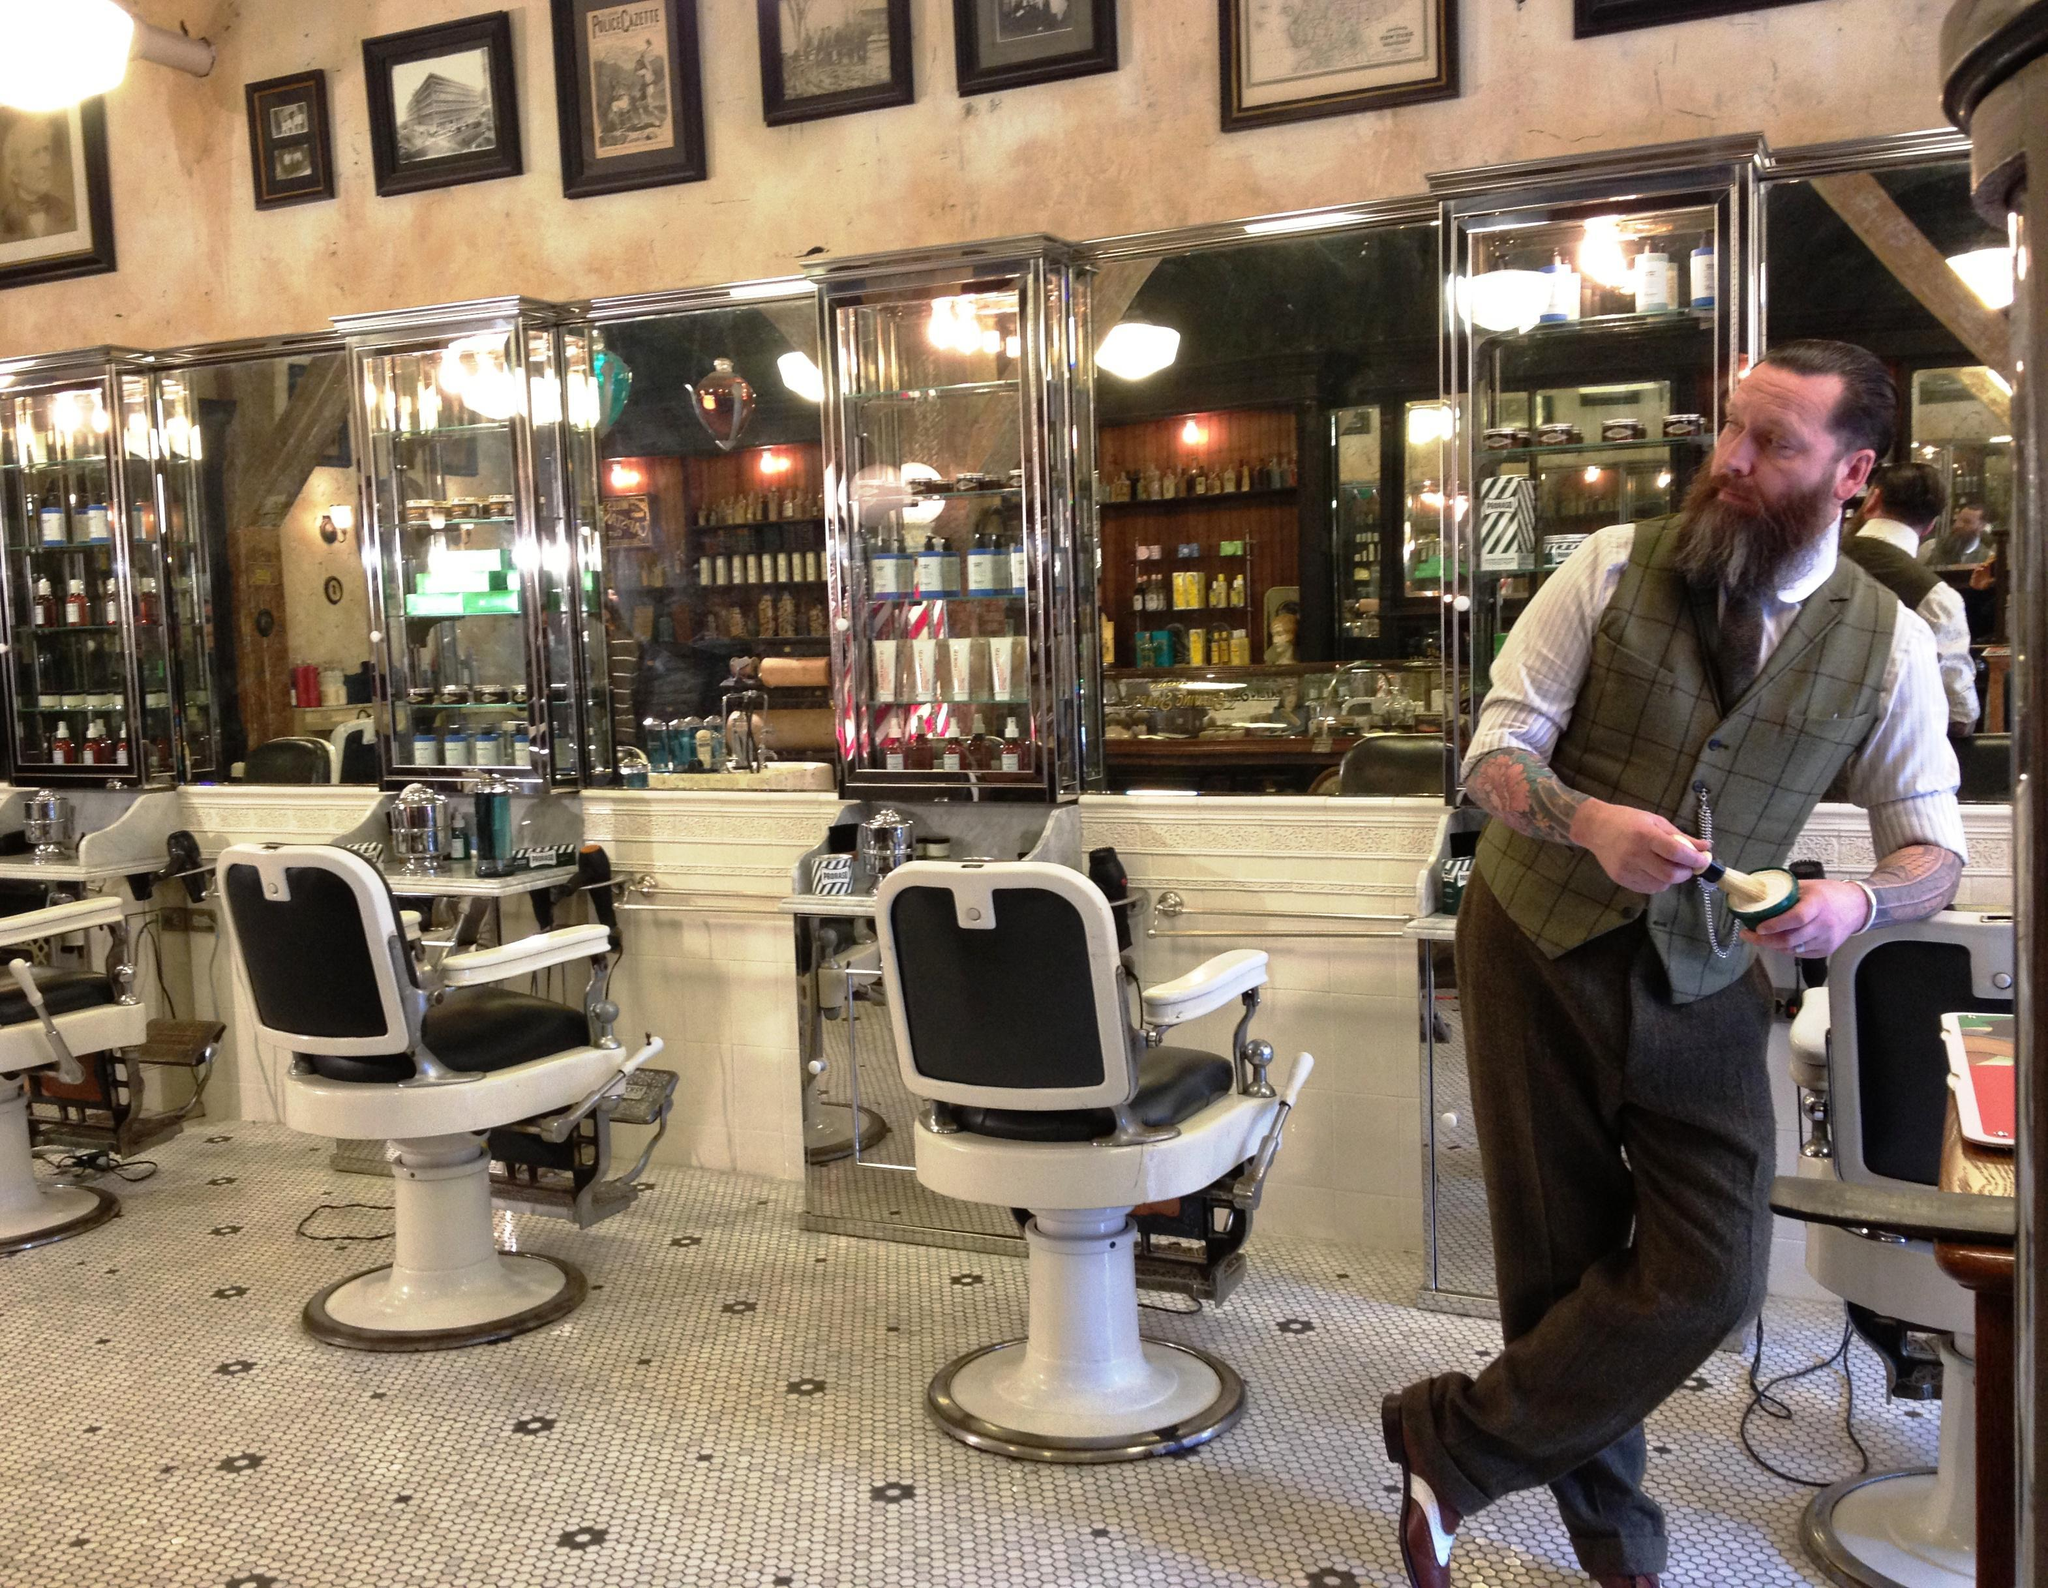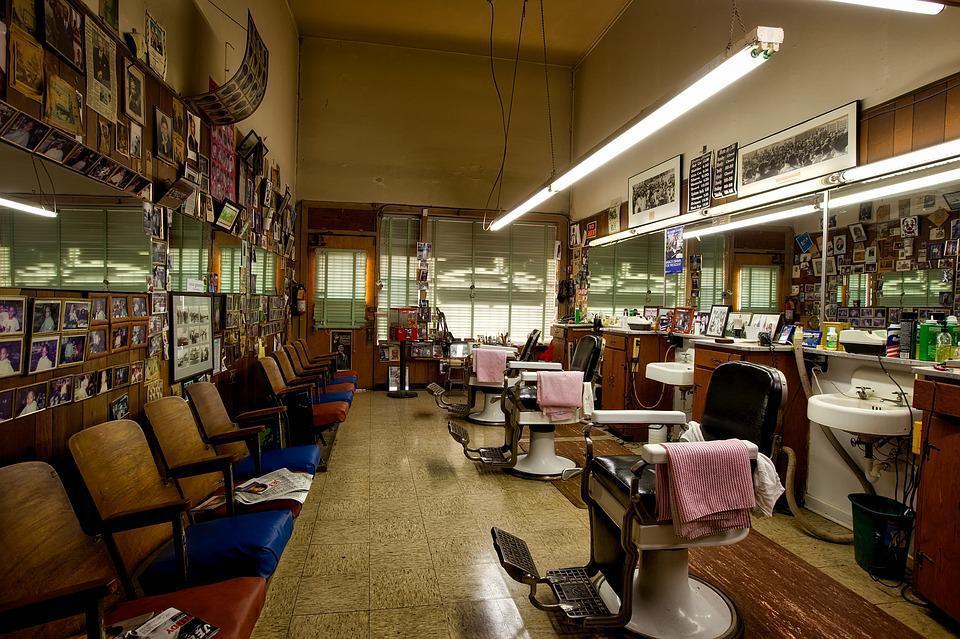The first image is the image on the left, the second image is the image on the right. Assess this claim about the two images: "There is at least one person at a barber shop.". Correct or not? Answer yes or no. Yes. 